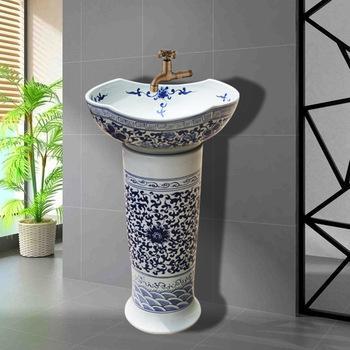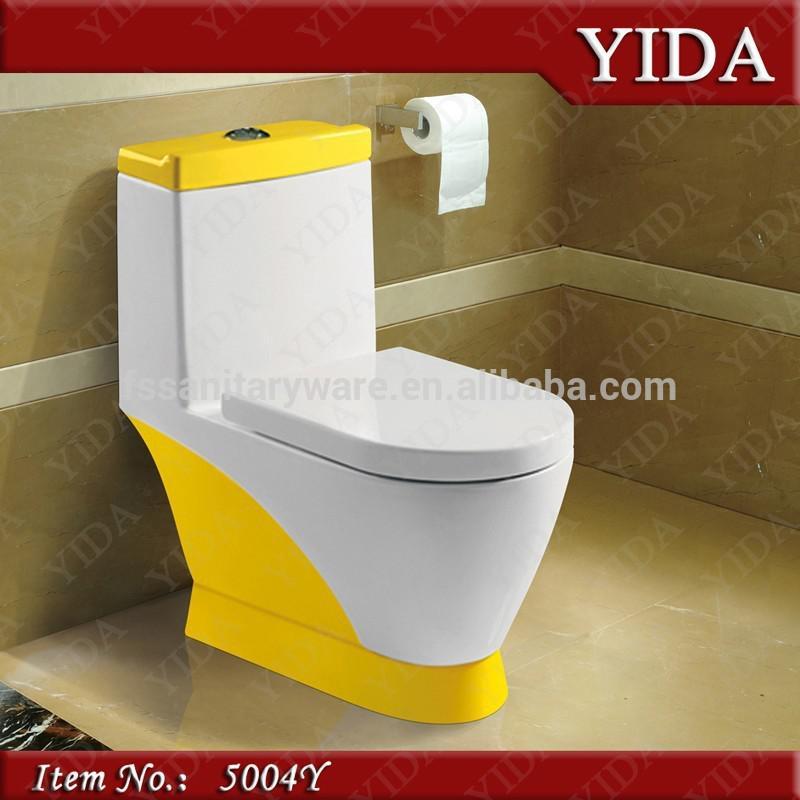The first image is the image on the left, the second image is the image on the right. Considering the images on both sides, is "At least part of a round mirror is visible above a rectangular vanity." valid? Answer yes or no. No. The first image is the image on the left, the second image is the image on the right. Analyze the images presented: Is the assertion "There is a silver colored sink, and a not-silver colored sink." valid? Answer yes or no. No. 